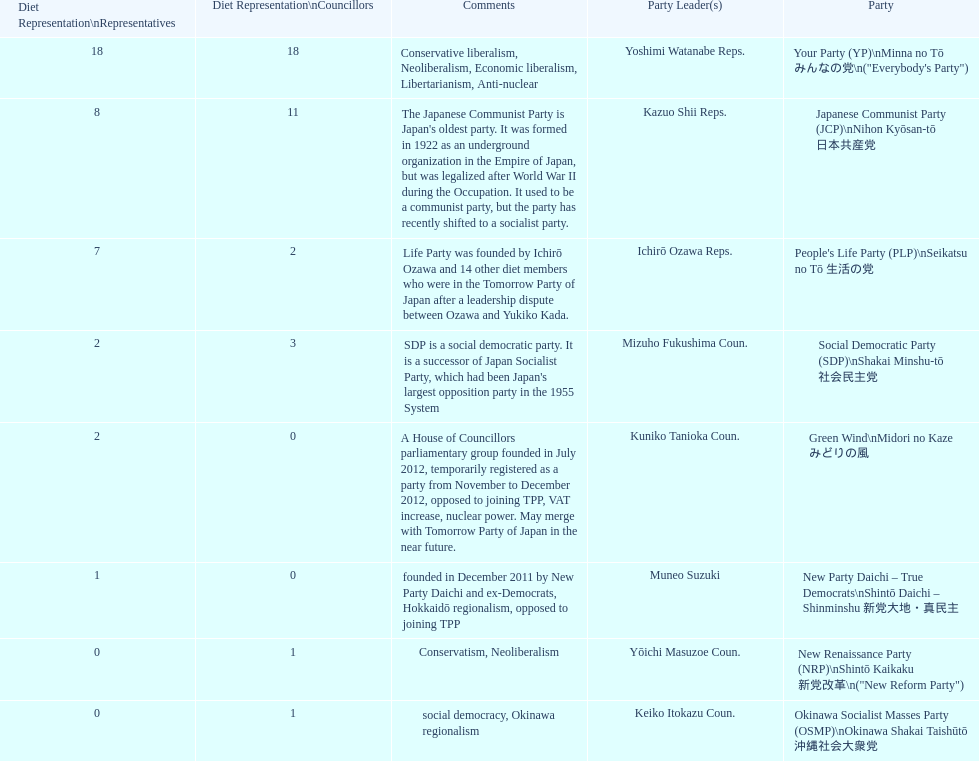How many of these parties currently have no councillors? 2. 